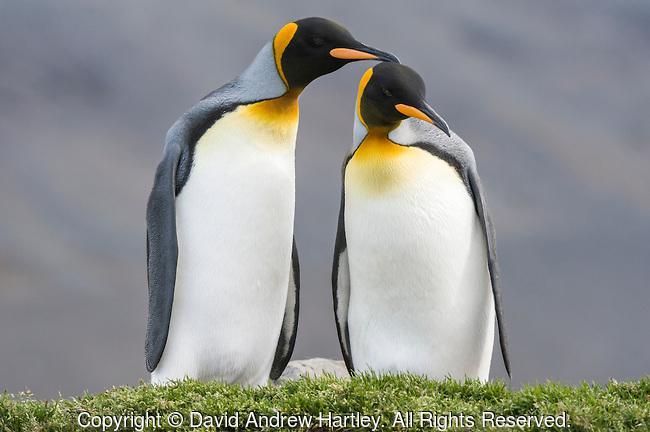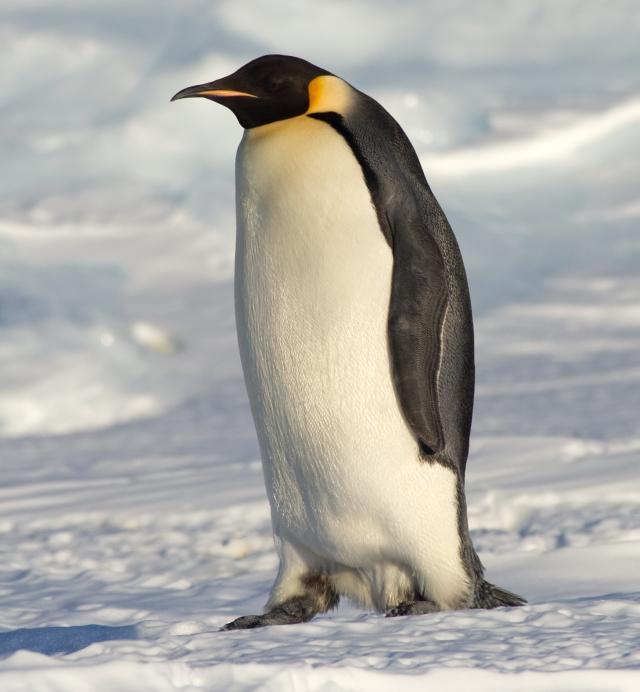The first image is the image on the left, the second image is the image on the right. For the images displayed, is the sentence "There are four penguins" factually correct? Answer yes or no. No. 